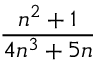<formula> <loc_0><loc_0><loc_500><loc_500>\frac { n ^ { 2 } + 1 } { 4 n ^ { 3 } + 5 n }</formula> 